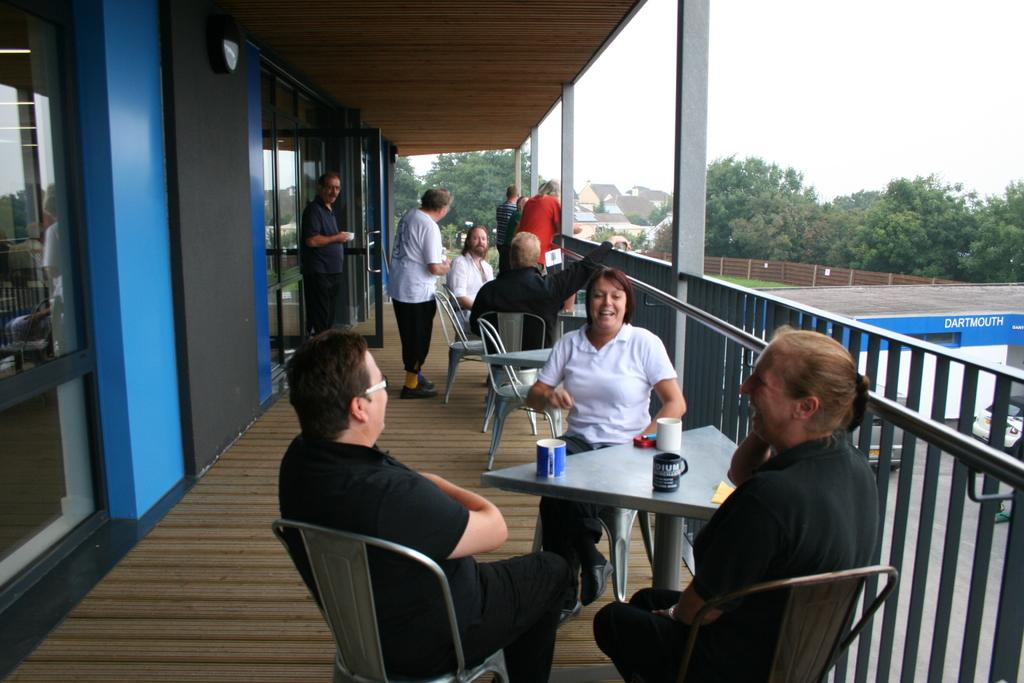What are the people in the image doing? The people in the image are sitting around a table. What type of doors can be seen in the image? There are glass doors in the image. What can be seen outside the glass doors? Trees are visible in the image. What type of barrier is present in the image? There is a fence in the image. What type of structures are visible in the image? There are buildings in the image. What feeling does the bit of cheese have in the image? There is no cheese present in the image, so it is not possible to determine the feeling of any cheese. 